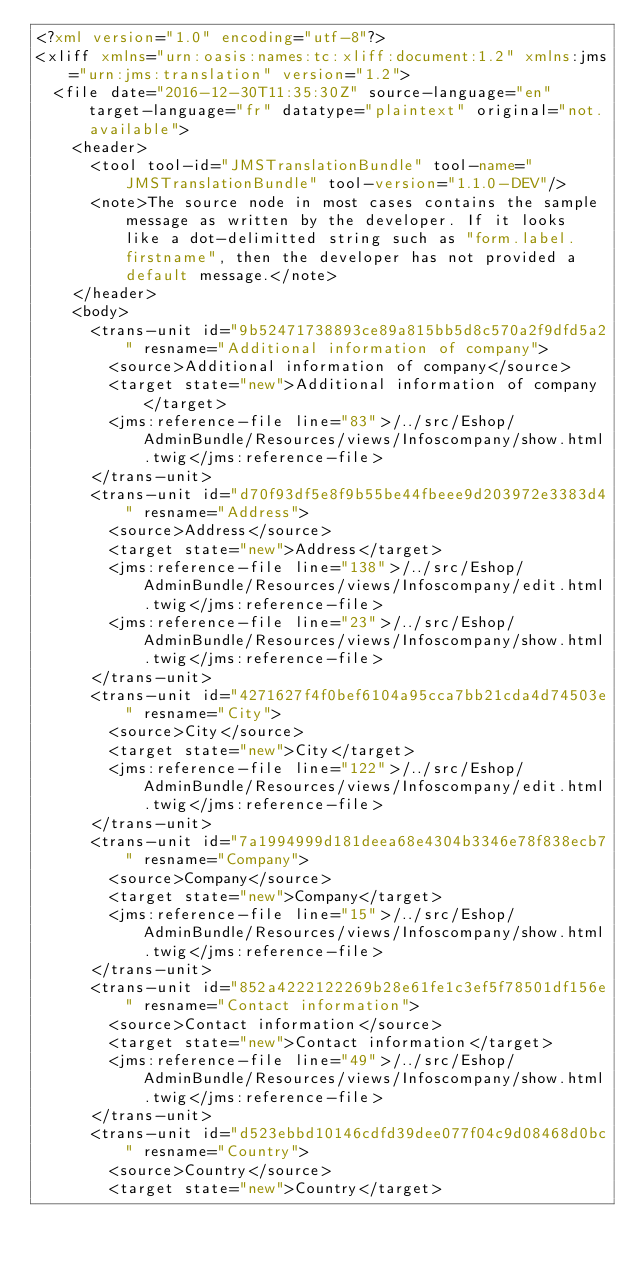<code> <loc_0><loc_0><loc_500><loc_500><_XML_><?xml version="1.0" encoding="utf-8"?>
<xliff xmlns="urn:oasis:names:tc:xliff:document:1.2" xmlns:jms="urn:jms:translation" version="1.2">
  <file date="2016-12-30T11:35:30Z" source-language="en" target-language="fr" datatype="plaintext" original="not.available">
    <header>
      <tool tool-id="JMSTranslationBundle" tool-name="JMSTranslationBundle" tool-version="1.1.0-DEV"/>
      <note>The source node in most cases contains the sample message as written by the developer. If it looks like a dot-delimitted string such as "form.label.firstname", then the developer has not provided a default message.</note>
    </header>
    <body>
      <trans-unit id="9b52471738893ce89a815bb5d8c570a2f9dfd5a2" resname="Additional information of company">
        <source>Additional information of company</source>
        <target state="new">Additional information of company</target>
        <jms:reference-file line="83">/../src/Eshop/AdminBundle/Resources/views/Infoscompany/show.html.twig</jms:reference-file>
      </trans-unit>
      <trans-unit id="d70f93df5e8f9b55be44fbeee9d203972e3383d4" resname="Address">
        <source>Address</source>
        <target state="new">Address</target>
        <jms:reference-file line="138">/../src/Eshop/AdminBundle/Resources/views/Infoscompany/edit.html.twig</jms:reference-file>
        <jms:reference-file line="23">/../src/Eshop/AdminBundle/Resources/views/Infoscompany/show.html.twig</jms:reference-file>
      </trans-unit>
      <trans-unit id="4271627f4f0bef6104a95cca7bb21cda4d74503e" resname="City">
        <source>City</source>
        <target state="new">City</target>
        <jms:reference-file line="122">/../src/Eshop/AdminBundle/Resources/views/Infoscompany/edit.html.twig</jms:reference-file>
      </trans-unit>
      <trans-unit id="7a1994999d181deea68e4304b3346e78f838ecb7" resname="Company">
        <source>Company</source>
        <target state="new">Company</target>
        <jms:reference-file line="15">/../src/Eshop/AdminBundle/Resources/views/Infoscompany/show.html.twig</jms:reference-file>
      </trans-unit>
      <trans-unit id="852a4222122269b28e61fe1c3ef5f78501df156e" resname="Contact information">
        <source>Contact information</source>
        <target state="new">Contact information</target>
        <jms:reference-file line="49">/../src/Eshop/AdminBundle/Resources/views/Infoscompany/show.html.twig</jms:reference-file>
      </trans-unit>
      <trans-unit id="d523ebbd10146cdfd39dee077f04c9d08468d0bc" resname="Country">
        <source>Country</source>
        <target state="new">Country</target></code> 